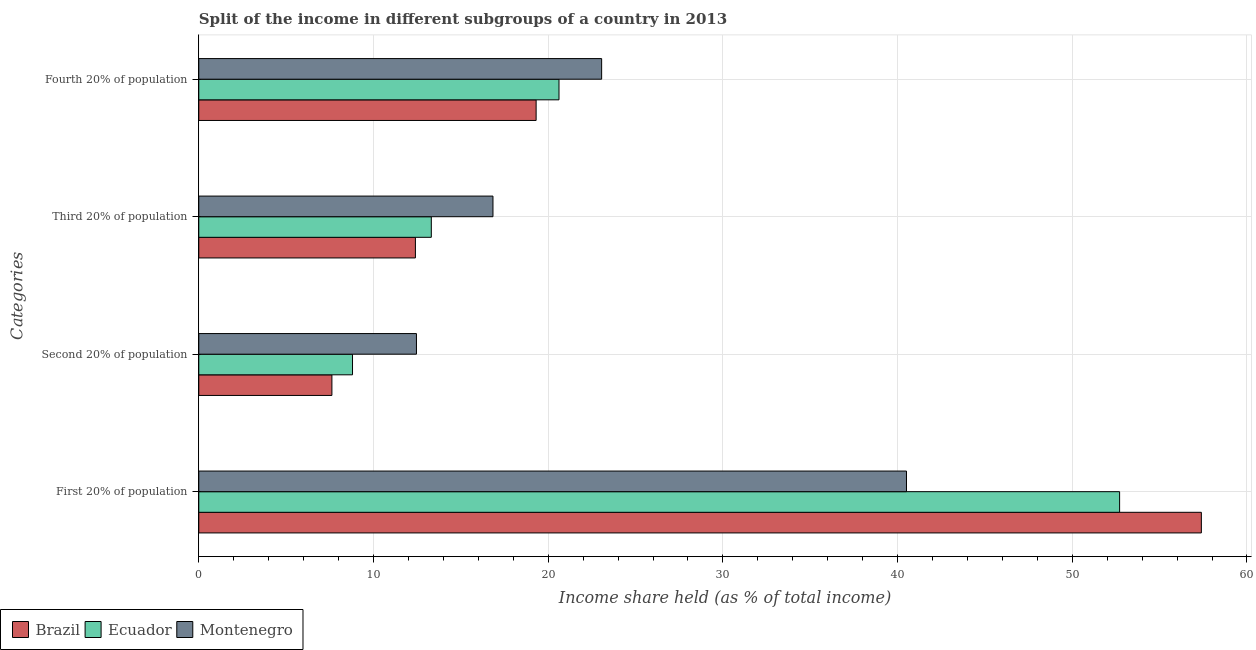Are the number of bars per tick equal to the number of legend labels?
Ensure brevity in your answer.  Yes. How many bars are there on the 3rd tick from the top?
Your answer should be compact. 3. What is the label of the 4th group of bars from the top?
Your answer should be very brief. First 20% of population. What is the share of the income held by third 20% of the population in Ecuador?
Offer a very short reply. 13.31. Across all countries, what is the maximum share of the income held by second 20% of the population?
Provide a short and direct response. 12.46. Across all countries, what is the minimum share of the income held by first 20% of the population?
Your answer should be compact. 40.51. In which country was the share of the income held by third 20% of the population maximum?
Your answer should be very brief. Montenegro. What is the total share of the income held by fourth 20% of the population in the graph?
Keep it short and to the point. 62.99. What is the difference between the share of the income held by third 20% of the population in Ecuador and that in Montenegro?
Make the answer very short. -3.53. What is the difference between the share of the income held by third 20% of the population in Brazil and the share of the income held by fourth 20% of the population in Ecuador?
Make the answer very short. -8.22. What is the average share of the income held by second 20% of the population per country?
Your answer should be compact. 9.63. What is the difference between the share of the income held by first 20% of the population and share of the income held by third 20% of the population in Montenegro?
Provide a succinct answer. 23.67. In how many countries, is the share of the income held by second 20% of the population greater than 34 %?
Ensure brevity in your answer.  0. What is the ratio of the share of the income held by third 20% of the population in Ecuador to that in Brazil?
Your answer should be compact. 1.07. What is the difference between the highest and the second highest share of the income held by first 20% of the population?
Provide a succinct answer. 4.68. What is the difference between the highest and the lowest share of the income held by second 20% of the population?
Offer a very short reply. 4.84. Is it the case that in every country, the sum of the share of the income held by second 20% of the population and share of the income held by fourth 20% of the population is greater than the sum of share of the income held by first 20% of the population and share of the income held by third 20% of the population?
Keep it short and to the point. Yes. What does the 2nd bar from the bottom in First 20% of population represents?
Your response must be concise. Ecuador. Is it the case that in every country, the sum of the share of the income held by first 20% of the population and share of the income held by second 20% of the population is greater than the share of the income held by third 20% of the population?
Offer a terse response. Yes. How many bars are there?
Provide a succinct answer. 12. Are all the bars in the graph horizontal?
Provide a succinct answer. Yes. What is the difference between two consecutive major ticks on the X-axis?
Your answer should be very brief. 10. Does the graph contain any zero values?
Provide a short and direct response. No. How many legend labels are there?
Make the answer very short. 3. How are the legend labels stacked?
Provide a short and direct response. Horizontal. What is the title of the graph?
Keep it short and to the point. Split of the income in different subgroups of a country in 2013. Does "Zambia" appear as one of the legend labels in the graph?
Keep it short and to the point. No. What is the label or title of the X-axis?
Your answer should be very brief. Income share held (as % of total income). What is the label or title of the Y-axis?
Your answer should be compact. Categories. What is the Income share held (as % of total income) of Brazil in First 20% of population?
Offer a very short reply. 57.39. What is the Income share held (as % of total income) in Ecuador in First 20% of population?
Ensure brevity in your answer.  52.71. What is the Income share held (as % of total income) of Montenegro in First 20% of population?
Your answer should be compact. 40.51. What is the Income share held (as % of total income) of Brazil in Second 20% of population?
Your answer should be compact. 7.62. What is the Income share held (as % of total income) in Ecuador in Second 20% of population?
Your answer should be compact. 8.8. What is the Income share held (as % of total income) of Montenegro in Second 20% of population?
Provide a short and direct response. 12.46. What is the Income share held (as % of total income) of Brazil in Third 20% of population?
Provide a succinct answer. 12.4. What is the Income share held (as % of total income) in Ecuador in Third 20% of population?
Provide a succinct answer. 13.31. What is the Income share held (as % of total income) of Montenegro in Third 20% of population?
Your response must be concise. 16.84. What is the Income share held (as % of total income) in Brazil in Fourth 20% of population?
Make the answer very short. 19.31. What is the Income share held (as % of total income) in Ecuador in Fourth 20% of population?
Your answer should be compact. 20.62. What is the Income share held (as % of total income) of Montenegro in Fourth 20% of population?
Ensure brevity in your answer.  23.06. Across all Categories, what is the maximum Income share held (as % of total income) of Brazil?
Ensure brevity in your answer.  57.39. Across all Categories, what is the maximum Income share held (as % of total income) of Ecuador?
Offer a very short reply. 52.71. Across all Categories, what is the maximum Income share held (as % of total income) of Montenegro?
Provide a short and direct response. 40.51. Across all Categories, what is the minimum Income share held (as % of total income) in Brazil?
Provide a short and direct response. 7.62. Across all Categories, what is the minimum Income share held (as % of total income) of Montenegro?
Provide a succinct answer. 12.46. What is the total Income share held (as % of total income) of Brazil in the graph?
Keep it short and to the point. 96.72. What is the total Income share held (as % of total income) in Ecuador in the graph?
Ensure brevity in your answer.  95.44. What is the total Income share held (as % of total income) in Montenegro in the graph?
Offer a terse response. 92.87. What is the difference between the Income share held (as % of total income) in Brazil in First 20% of population and that in Second 20% of population?
Ensure brevity in your answer.  49.77. What is the difference between the Income share held (as % of total income) of Ecuador in First 20% of population and that in Second 20% of population?
Make the answer very short. 43.91. What is the difference between the Income share held (as % of total income) in Montenegro in First 20% of population and that in Second 20% of population?
Your answer should be compact. 28.05. What is the difference between the Income share held (as % of total income) in Brazil in First 20% of population and that in Third 20% of population?
Provide a succinct answer. 44.99. What is the difference between the Income share held (as % of total income) of Ecuador in First 20% of population and that in Third 20% of population?
Your answer should be compact. 39.4. What is the difference between the Income share held (as % of total income) of Montenegro in First 20% of population and that in Third 20% of population?
Ensure brevity in your answer.  23.67. What is the difference between the Income share held (as % of total income) in Brazil in First 20% of population and that in Fourth 20% of population?
Keep it short and to the point. 38.08. What is the difference between the Income share held (as % of total income) in Ecuador in First 20% of population and that in Fourth 20% of population?
Provide a short and direct response. 32.09. What is the difference between the Income share held (as % of total income) in Montenegro in First 20% of population and that in Fourth 20% of population?
Provide a short and direct response. 17.45. What is the difference between the Income share held (as % of total income) in Brazil in Second 20% of population and that in Third 20% of population?
Offer a very short reply. -4.78. What is the difference between the Income share held (as % of total income) in Ecuador in Second 20% of population and that in Third 20% of population?
Offer a very short reply. -4.51. What is the difference between the Income share held (as % of total income) in Montenegro in Second 20% of population and that in Third 20% of population?
Provide a succinct answer. -4.38. What is the difference between the Income share held (as % of total income) in Brazil in Second 20% of population and that in Fourth 20% of population?
Offer a terse response. -11.69. What is the difference between the Income share held (as % of total income) of Ecuador in Second 20% of population and that in Fourth 20% of population?
Provide a succinct answer. -11.82. What is the difference between the Income share held (as % of total income) of Montenegro in Second 20% of population and that in Fourth 20% of population?
Ensure brevity in your answer.  -10.6. What is the difference between the Income share held (as % of total income) of Brazil in Third 20% of population and that in Fourth 20% of population?
Offer a terse response. -6.91. What is the difference between the Income share held (as % of total income) in Ecuador in Third 20% of population and that in Fourth 20% of population?
Your response must be concise. -7.31. What is the difference between the Income share held (as % of total income) in Montenegro in Third 20% of population and that in Fourth 20% of population?
Offer a terse response. -6.22. What is the difference between the Income share held (as % of total income) in Brazil in First 20% of population and the Income share held (as % of total income) in Ecuador in Second 20% of population?
Offer a very short reply. 48.59. What is the difference between the Income share held (as % of total income) in Brazil in First 20% of population and the Income share held (as % of total income) in Montenegro in Second 20% of population?
Your answer should be very brief. 44.93. What is the difference between the Income share held (as % of total income) of Ecuador in First 20% of population and the Income share held (as % of total income) of Montenegro in Second 20% of population?
Your answer should be very brief. 40.25. What is the difference between the Income share held (as % of total income) of Brazil in First 20% of population and the Income share held (as % of total income) of Ecuador in Third 20% of population?
Your answer should be very brief. 44.08. What is the difference between the Income share held (as % of total income) of Brazil in First 20% of population and the Income share held (as % of total income) of Montenegro in Third 20% of population?
Keep it short and to the point. 40.55. What is the difference between the Income share held (as % of total income) of Ecuador in First 20% of population and the Income share held (as % of total income) of Montenegro in Third 20% of population?
Provide a succinct answer. 35.87. What is the difference between the Income share held (as % of total income) in Brazil in First 20% of population and the Income share held (as % of total income) in Ecuador in Fourth 20% of population?
Provide a short and direct response. 36.77. What is the difference between the Income share held (as % of total income) of Brazil in First 20% of population and the Income share held (as % of total income) of Montenegro in Fourth 20% of population?
Keep it short and to the point. 34.33. What is the difference between the Income share held (as % of total income) in Ecuador in First 20% of population and the Income share held (as % of total income) in Montenegro in Fourth 20% of population?
Offer a very short reply. 29.65. What is the difference between the Income share held (as % of total income) in Brazil in Second 20% of population and the Income share held (as % of total income) in Ecuador in Third 20% of population?
Keep it short and to the point. -5.69. What is the difference between the Income share held (as % of total income) of Brazil in Second 20% of population and the Income share held (as % of total income) of Montenegro in Third 20% of population?
Give a very brief answer. -9.22. What is the difference between the Income share held (as % of total income) of Ecuador in Second 20% of population and the Income share held (as % of total income) of Montenegro in Third 20% of population?
Your answer should be compact. -8.04. What is the difference between the Income share held (as % of total income) of Brazil in Second 20% of population and the Income share held (as % of total income) of Montenegro in Fourth 20% of population?
Make the answer very short. -15.44. What is the difference between the Income share held (as % of total income) of Ecuador in Second 20% of population and the Income share held (as % of total income) of Montenegro in Fourth 20% of population?
Your answer should be very brief. -14.26. What is the difference between the Income share held (as % of total income) in Brazil in Third 20% of population and the Income share held (as % of total income) in Ecuador in Fourth 20% of population?
Keep it short and to the point. -8.22. What is the difference between the Income share held (as % of total income) in Brazil in Third 20% of population and the Income share held (as % of total income) in Montenegro in Fourth 20% of population?
Ensure brevity in your answer.  -10.66. What is the difference between the Income share held (as % of total income) in Ecuador in Third 20% of population and the Income share held (as % of total income) in Montenegro in Fourth 20% of population?
Make the answer very short. -9.75. What is the average Income share held (as % of total income) of Brazil per Categories?
Your answer should be compact. 24.18. What is the average Income share held (as % of total income) in Ecuador per Categories?
Your answer should be very brief. 23.86. What is the average Income share held (as % of total income) in Montenegro per Categories?
Keep it short and to the point. 23.22. What is the difference between the Income share held (as % of total income) of Brazil and Income share held (as % of total income) of Ecuador in First 20% of population?
Provide a succinct answer. 4.68. What is the difference between the Income share held (as % of total income) of Brazil and Income share held (as % of total income) of Montenegro in First 20% of population?
Your response must be concise. 16.88. What is the difference between the Income share held (as % of total income) of Brazil and Income share held (as % of total income) of Ecuador in Second 20% of population?
Provide a succinct answer. -1.18. What is the difference between the Income share held (as % of total income) in Brazil and Income share held (as % of total income) in Montenegro in Second 20% of population?
Offer a very short reply. -4.84. What is the difference between the Income share held (as % of total income) in Ecuador and Income share held (as % of total income) in Montenegro in Second 20% of population?
Your response must be concise. -3.66. What is the difference between the Income share held (as % of total income) in Brazil and Income share held (as % of total income) in Ecuador in Third 20% of population?
Offer a terse response. -0.91. What is the difference between the Income share held (as % of total income) of Brazil and Income share held (as % of total income) of Montenegro in Third 20% of population?
Keep it short and to the point. -4.44. What is the difference between the Income share held (as % of total income) of Ecuador and Income share held (as % of total income) of Montenegro in Third 20% of population?
Give a very brief answer. -3.53. What is the difference between the Income share held (as % of total income) of Brazil and Income share held (as % of total income) of Ecuador in Fourth 20% of population?
Make the answer very short. -1.31. What is the difference between the Income share held (as % of total income) in Brazil and Income share held (as % of total income) in Montenegro in Fourth 20% of population?
Provide a short and direct response. -3.75. What is the difference between the Income share held (as % of total income) in Ecuador and Income share held (as % of total income) in Montenegro in Fourth 20% of population?
Provide a succinct answer. -2.44. What is the ratio of the Income share held (as % of total income) of Brazil in First 20% of population to that in Second 20% of population?
Make the answer very short. 7.53. What is the ratio of the Income share held (as % of total income) of Ecuador in First 20% of population to that in Second 20% of population?
Your response must be concise. 5.99. What is the ratio of the Income share held (as % of total income) of Montenegro in First 20% of population to that in Second 20% of population?
Your answer should be very brief. 3.25. What is the ratio of the Income share held (as % of total income) of Brazil in First 20% of population to that in Third 20% of population?
Your answer should be very brief. 4.63. What is the ratio of the Income share held (as % of total income) in Ecuador in First 20% of population to that in Third 20% of population?
Your answer should be compact. 3.96. What is the ratio of the Income share held (as % of total income) of Montenegro in First 20% of population to that in Third 20% of population?
Ensure brevity in your answer.  2.41. What is the ratio of the Income share held (as % of total income) of Brazil in First 20% of population to that in Fourth 20% of population?
Your answer should be very brief. 2.97. What is the ratio of the Income share held (as % of total income) in Ecuador in First 20% of population to that in Fourth 20% of population?
Your response must be concise. 2.56. What is the ratio of the Income share held (as % of total income) in Montenegro in First 20% of population to that in Fourth 20% of population?
Your answer should be compact. 1.76. What is the ratio of the Income share held (as % of total income) in Brazil in Second 20% of population to that in Third 20% of population?
Ensure brevity in your answer.  0.61. What is the ratio of the Income share held (as % of total income) in Ecuador in Second 20% of population to that in Third 20% of population?
Make the answer very short. 0.66. What is the ratio of the Income share held (as % of total income) of Montenegro in Second 20% of population to that in Third 20% of population?
Give a very brief answer. 0.74. What is the ratio of the Income share held (as % of total income) of Brazil in Second 20% of population to that in Fourth 20% of population?
Your answer should be very brief. 0.39. What is the ratio of the Income share held (as % of total income) of Ecuador in Second 20% of population to that in Fourth 20% of population?
Give a very brief answer. 0.43. What is the ratio of the Income share held (as % of total income) in Montenegro in Second 20% of population to that in Fourth 20% of population?
Provide a short and direct response. 0.54. What is the ratio of the Income share held (as % of total income) in Brazil in Third 20% of population to that in Fourth 20% of population?
Offer a terse response. 0.64. What is the ratio of the Income share held (as % of total income) of Ecuador in Third 20% of population to that in Fourth 20% of population?
Make the answer very short. 0.65. What is the ratio of the Income share held (as % of total income) in Montenegro in Third 20% of population to that in Fourth 20% of population?
Your answer should be compact. 0.73. What is the difference between the highest and the second highest Income share held (as % of total income) of Brazil?
Keep it short and to the point. 38.08. What is the difference between the highest and the second highest Income share held (as % of total income) of Ecuador?
Provide a short and direct response. 32.09. What is the difference between the highest and the second highest Income share held (as % of total income) in Montenegro?
Ensure brevity in your answer.  17.45. What is the difference between the highest and the lowest Income share held (as % of total income) in Brazil?
Offer a very short reply. 49.77. What is the difference between the highest and the lowest Income share held (as % of total income) of Ecuador?
Your answer should be very brief. 43.91. What is the difference between the highest and the lowest Income share held (as % of total income) of Montenegro?
Provide a short and direct response. 28.05. 